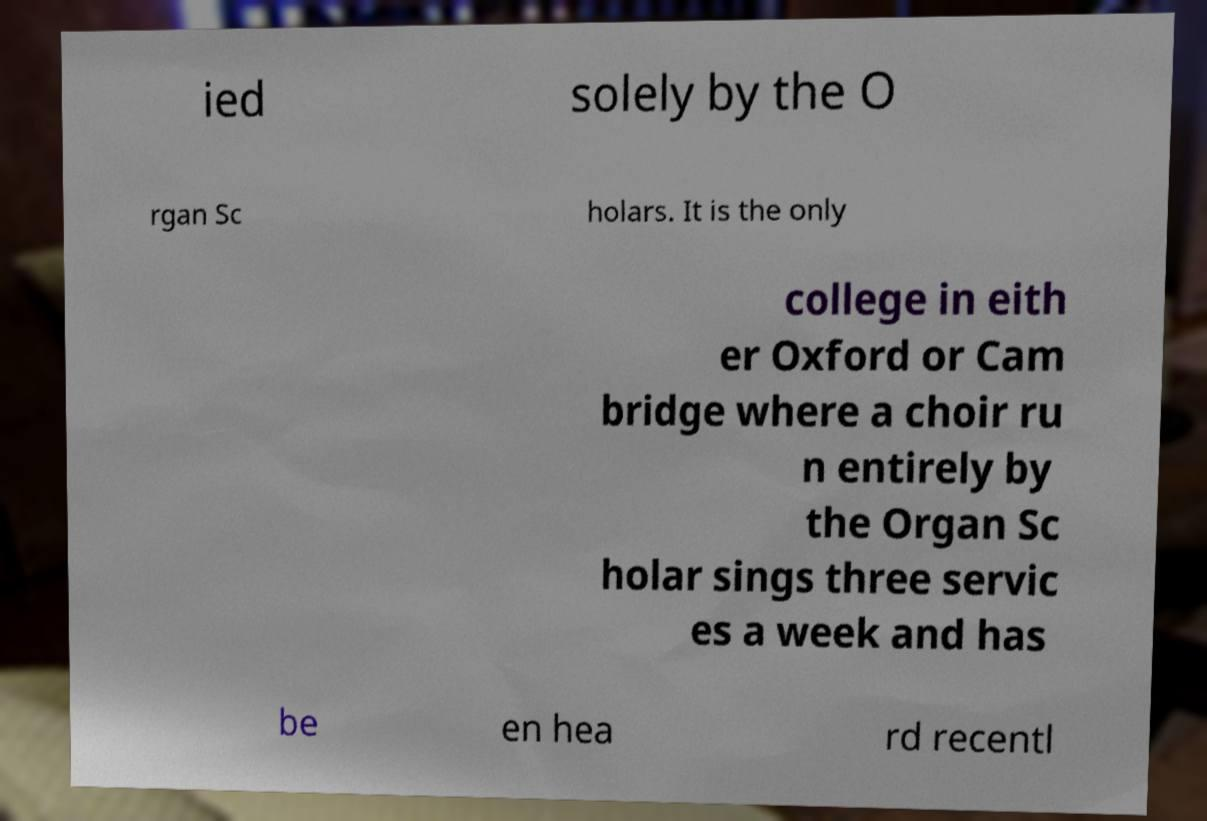Please read and relay the text visible in this image. What does it say? ied solely by the O rgan Sc holars. It is the only college in eith er Oxford or Cam bridge where a choir ru n entirely by the Organ Sc holar sings three servic es a week and has be en hea rd recentl 